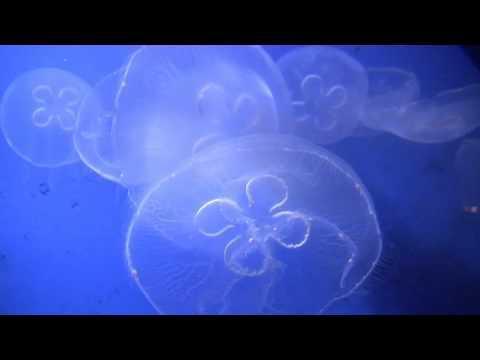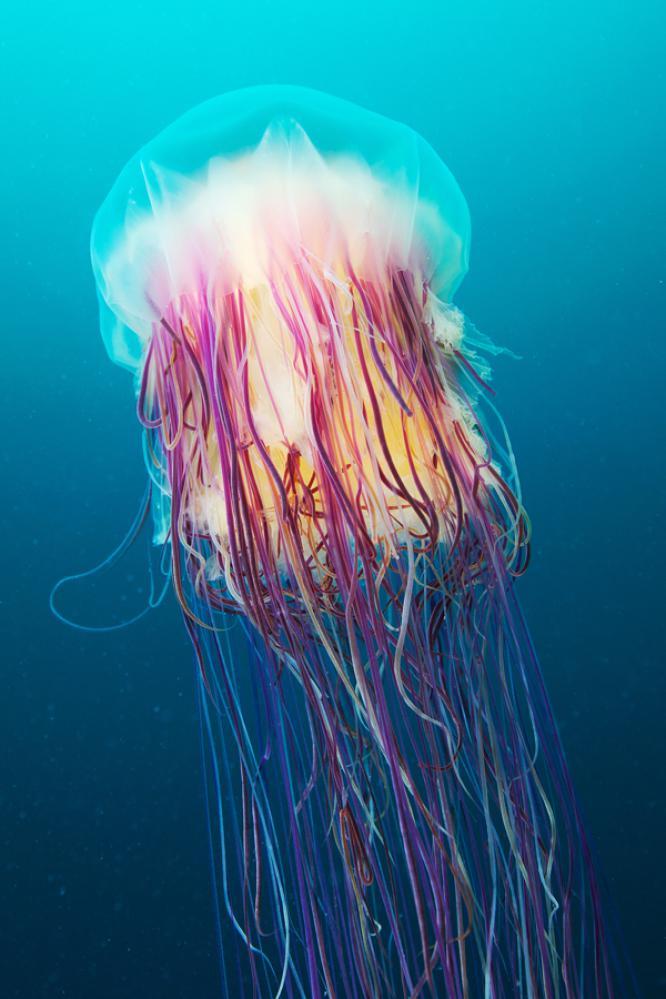The first image is the image on the left, the second image is the image on the right. Assess this claim about the two images: "the jellyfish in the left image is swimming to the right". Correct or not? Answer yes or no. No. The first image is the image on the left, the second image is the image on the right. Given the left and right images, does the statement "The jellyfish in the image to the left has a distinct clover type image visible within its body." hold true? Answer yes or no. Yes. 